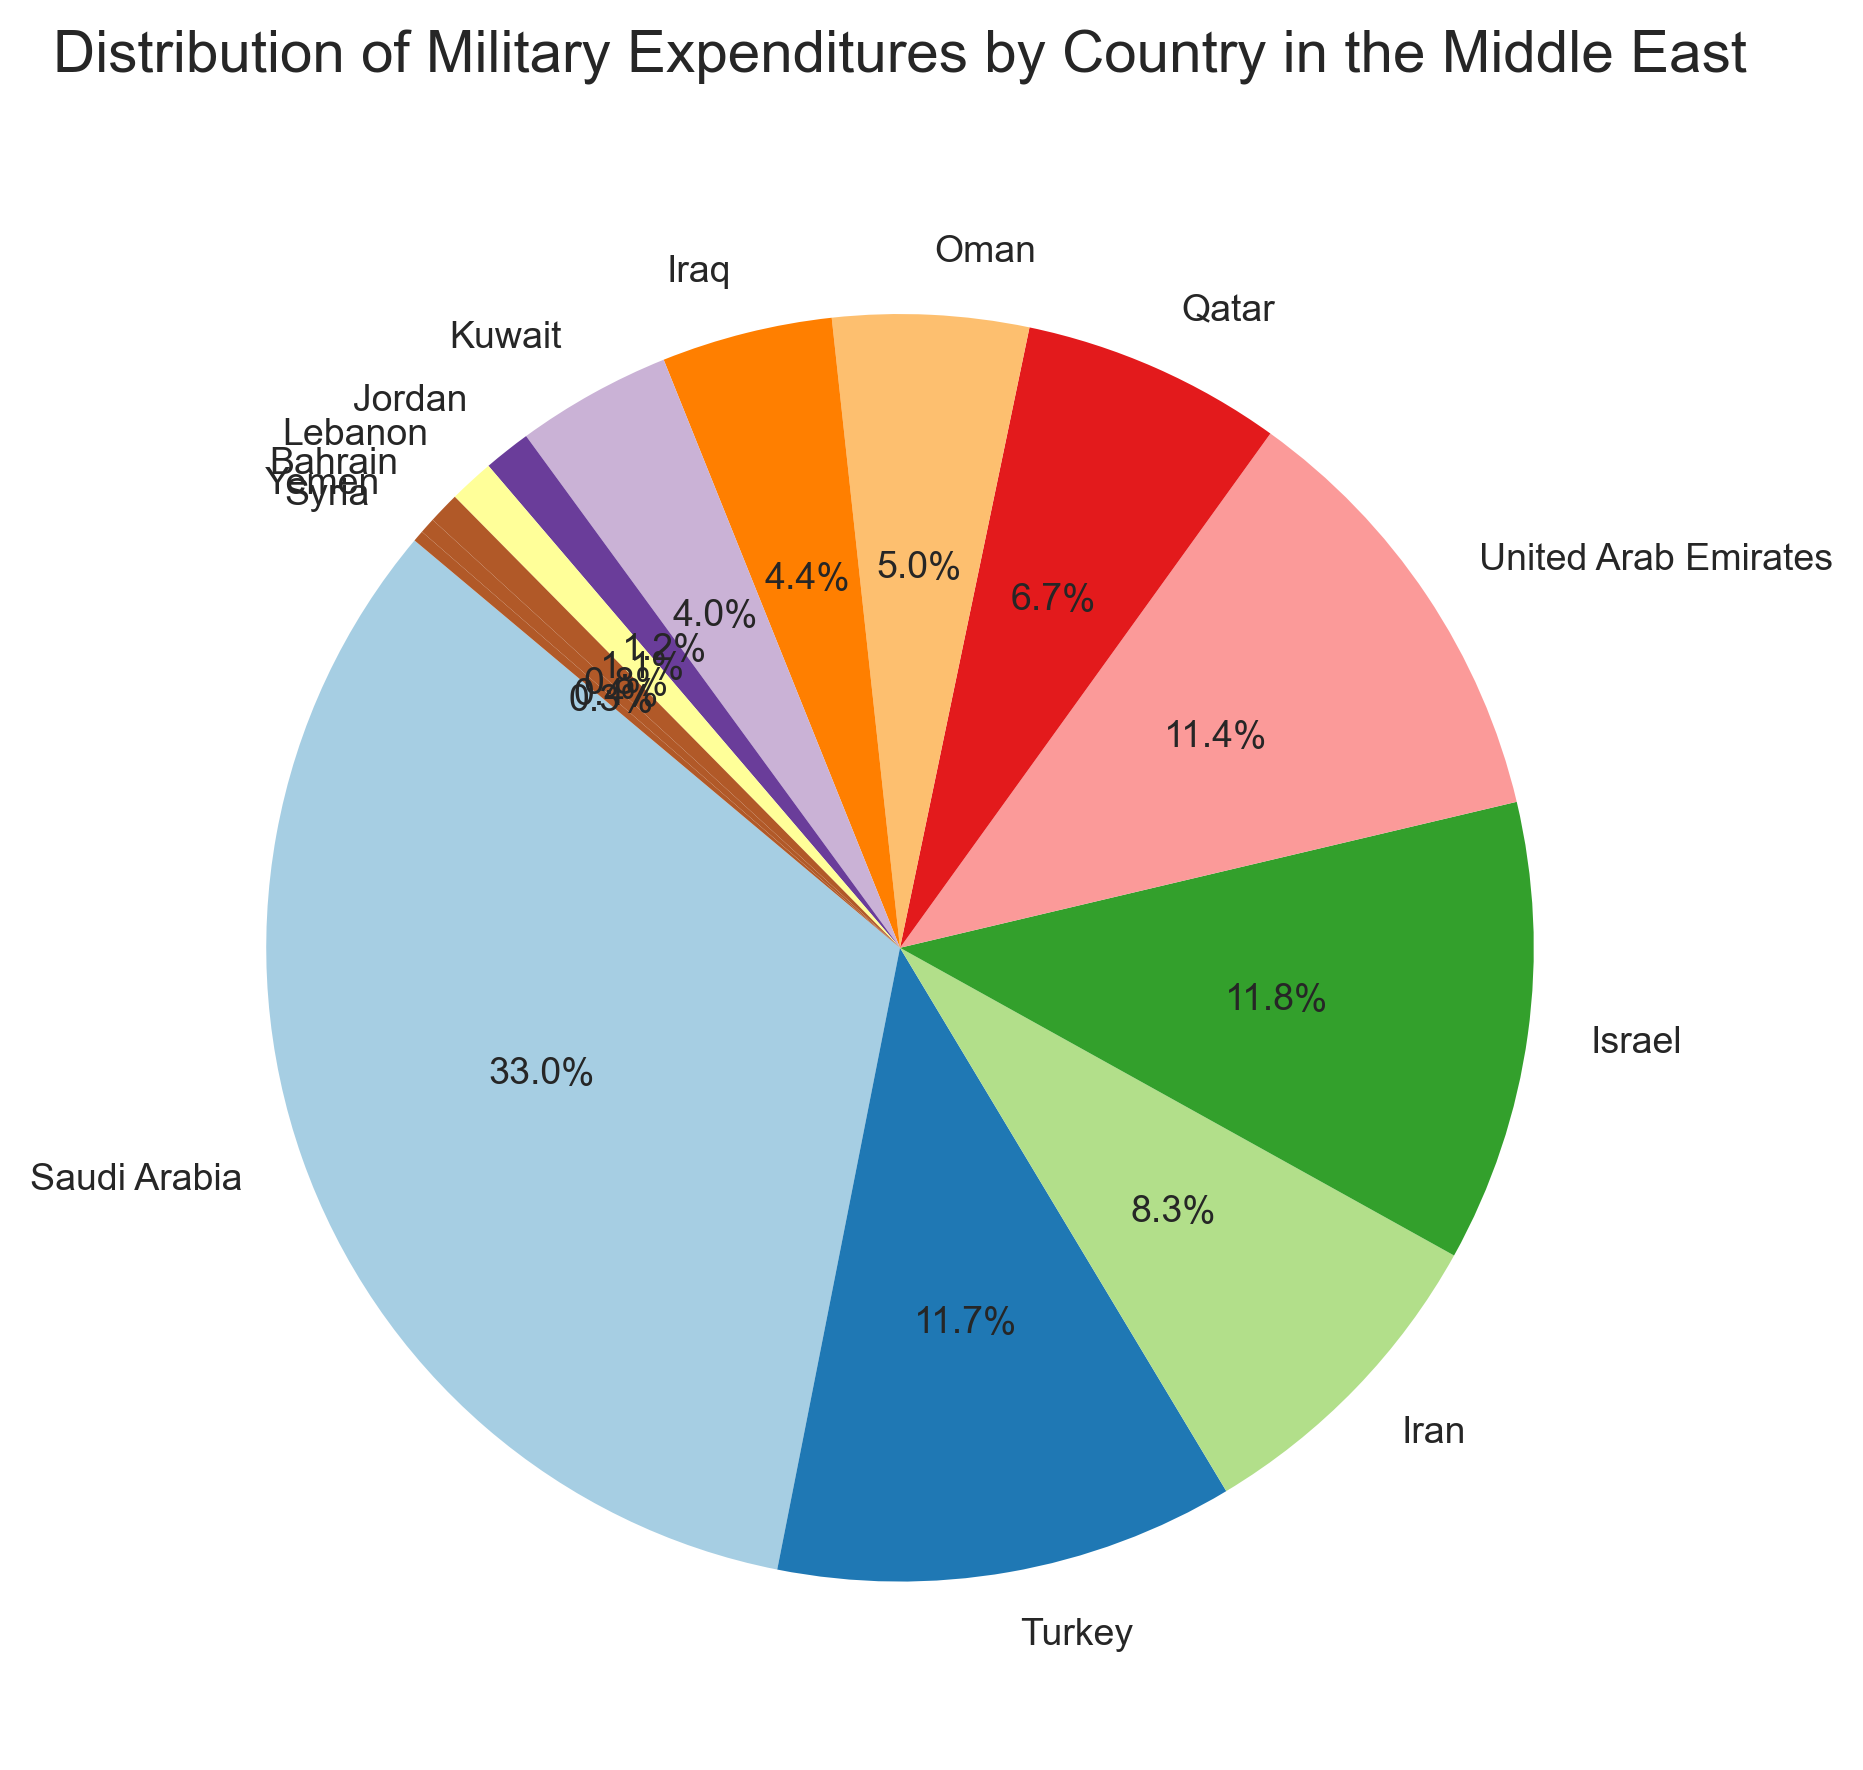Which country has the highest military expenditure in the Middle East? From the pie chart, it is evident that Saudi Arabia has the largest slice, indicating it has the highest expenditure.
Answer: Saudi Arabia Which country has the lowest military expenditure in the Middle East? Observing the pie chart, the smallest slice belongs to Syria, indicating the lowest expenditure.
Answer: Syria What is the combined military expenditure of Turkey and Israel? According to the pie chart, Turkey's expenditure is 20.4 billion USD and Israel's is 20.5 billion USD. Adding these two: 20.4 + 20.5 = 40.9 billion USD.
Answer: 40.9 billion USD Is the military expenditure of the United Arab Emirates greater or less than that of Iran? From the chart, the slice representing the United Arab Emirates is slightly larger than that of Iran. Thus, the UAE's expenditure is greater.
Answer: Greater How many countries have a military expenditure greater than 10 billion USD? By looking at the chart, we can identify Saudi Arabia, Turkey, Israel, UAE, and Qatar as having expenditures greater than 10 billion USD. This makes a total of 5 countries.
Answer: 5 What percentage of the total military expenditure is shared by Saudi Arabia and Oman combined? The chart indicates Saudi Arabia's expenditure as 57.5 billion USD and Oman's as 8.7 billion USD. Combined: 57.5 + 8.7 = 66.2 billion USD. The total expenditure of all countries is 174.2 billion USD. So, (66.2 / 174.2) * 100 = 38%.
Answer: 38% What is the difference in military expenditure between Saudi Arabia and Qatar? Saudi Arabia's expenditure is 57.5 billion USD, while Qatar's is 11.6 billion USD. The difference is 57.5 - 11.6 = 45.9 billion USD.
Answer: 45.9 billion USD Which country has a slightly higher military expenditure: Iraq or Kuwait? From the pie chart, Iraq's expenditure is 7.6 billion USD, whereas Kuwait's is 6.9 billion USD. Thus, Iraq has a slightly higher expenditure.
Answer: Iraq What is the average military expenditure of Jordan, Lebanon, Bahrain, Yemen, and Syria? The expenditures are Jordan: 2.1 billion, Lebanon: 2.0 billion, Bahrain: 1.4 billion, Yemen: 0.7 billion, and Syria: 0.5 billion USD. The total is 2.1 + 2.0 + 1.4 + 0.7 + 0.5 = 6.7 billion USD. The average is 6.7 / 5 = 1.34 billion USD.
Answer: 1.34 billion USD By how much does Yemen's military expenditure exceed Syria's? Yemen's expenditure is 0.7 billion USD, and Syria's is 0.5 billion USD. The difference is 0.7 - 0.5 = 0.2 billion USD.
Answer: 0.2 billion USD 